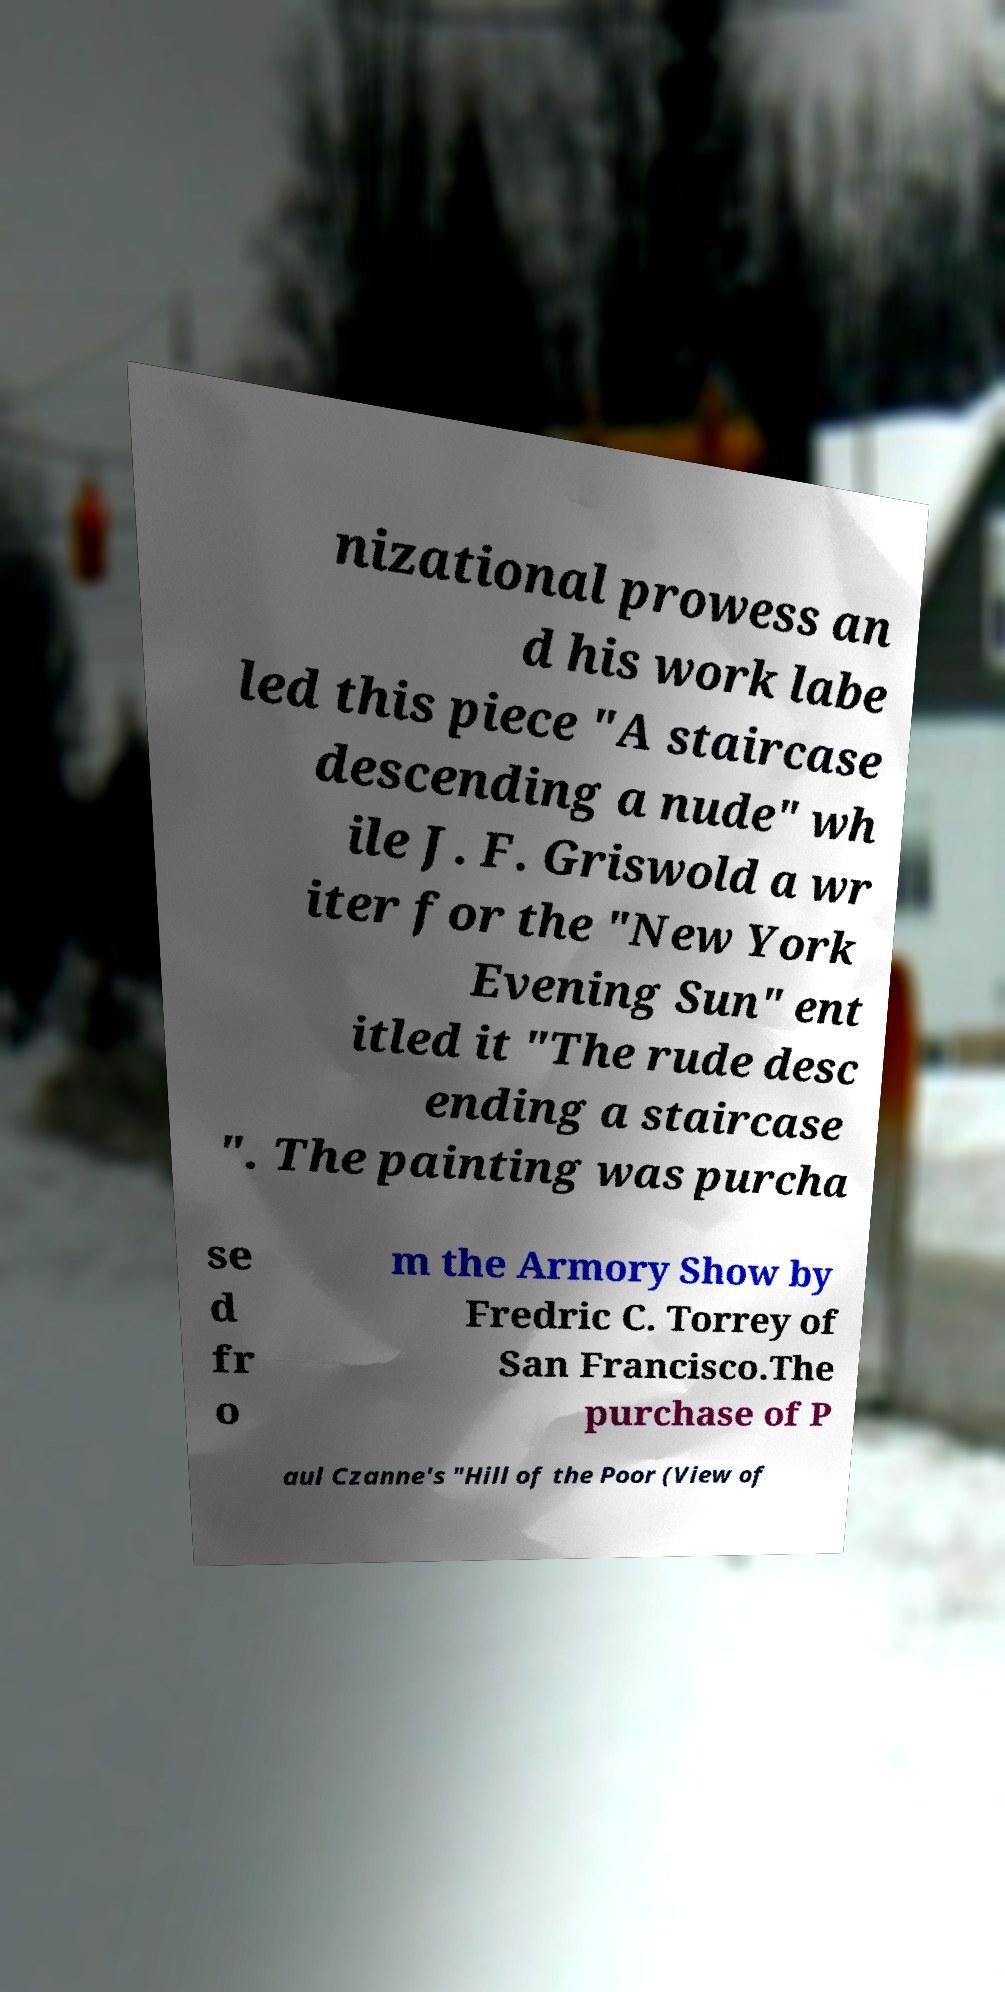Can you accurately transcribe the text from the provided image for me? nizational prowess an d his work labe led this piece "A staircase descending a nude" wh ile J. F. Griswold a wr iter for the "New York Evening Sun" ent itled it "The rude desc ending a staircase ". The painting was purcha se d fr o m the Armory Show by Fredric C. Torrey of San Francisco.The purchase of P aul Czanne's "Hill of the Poor (View of 